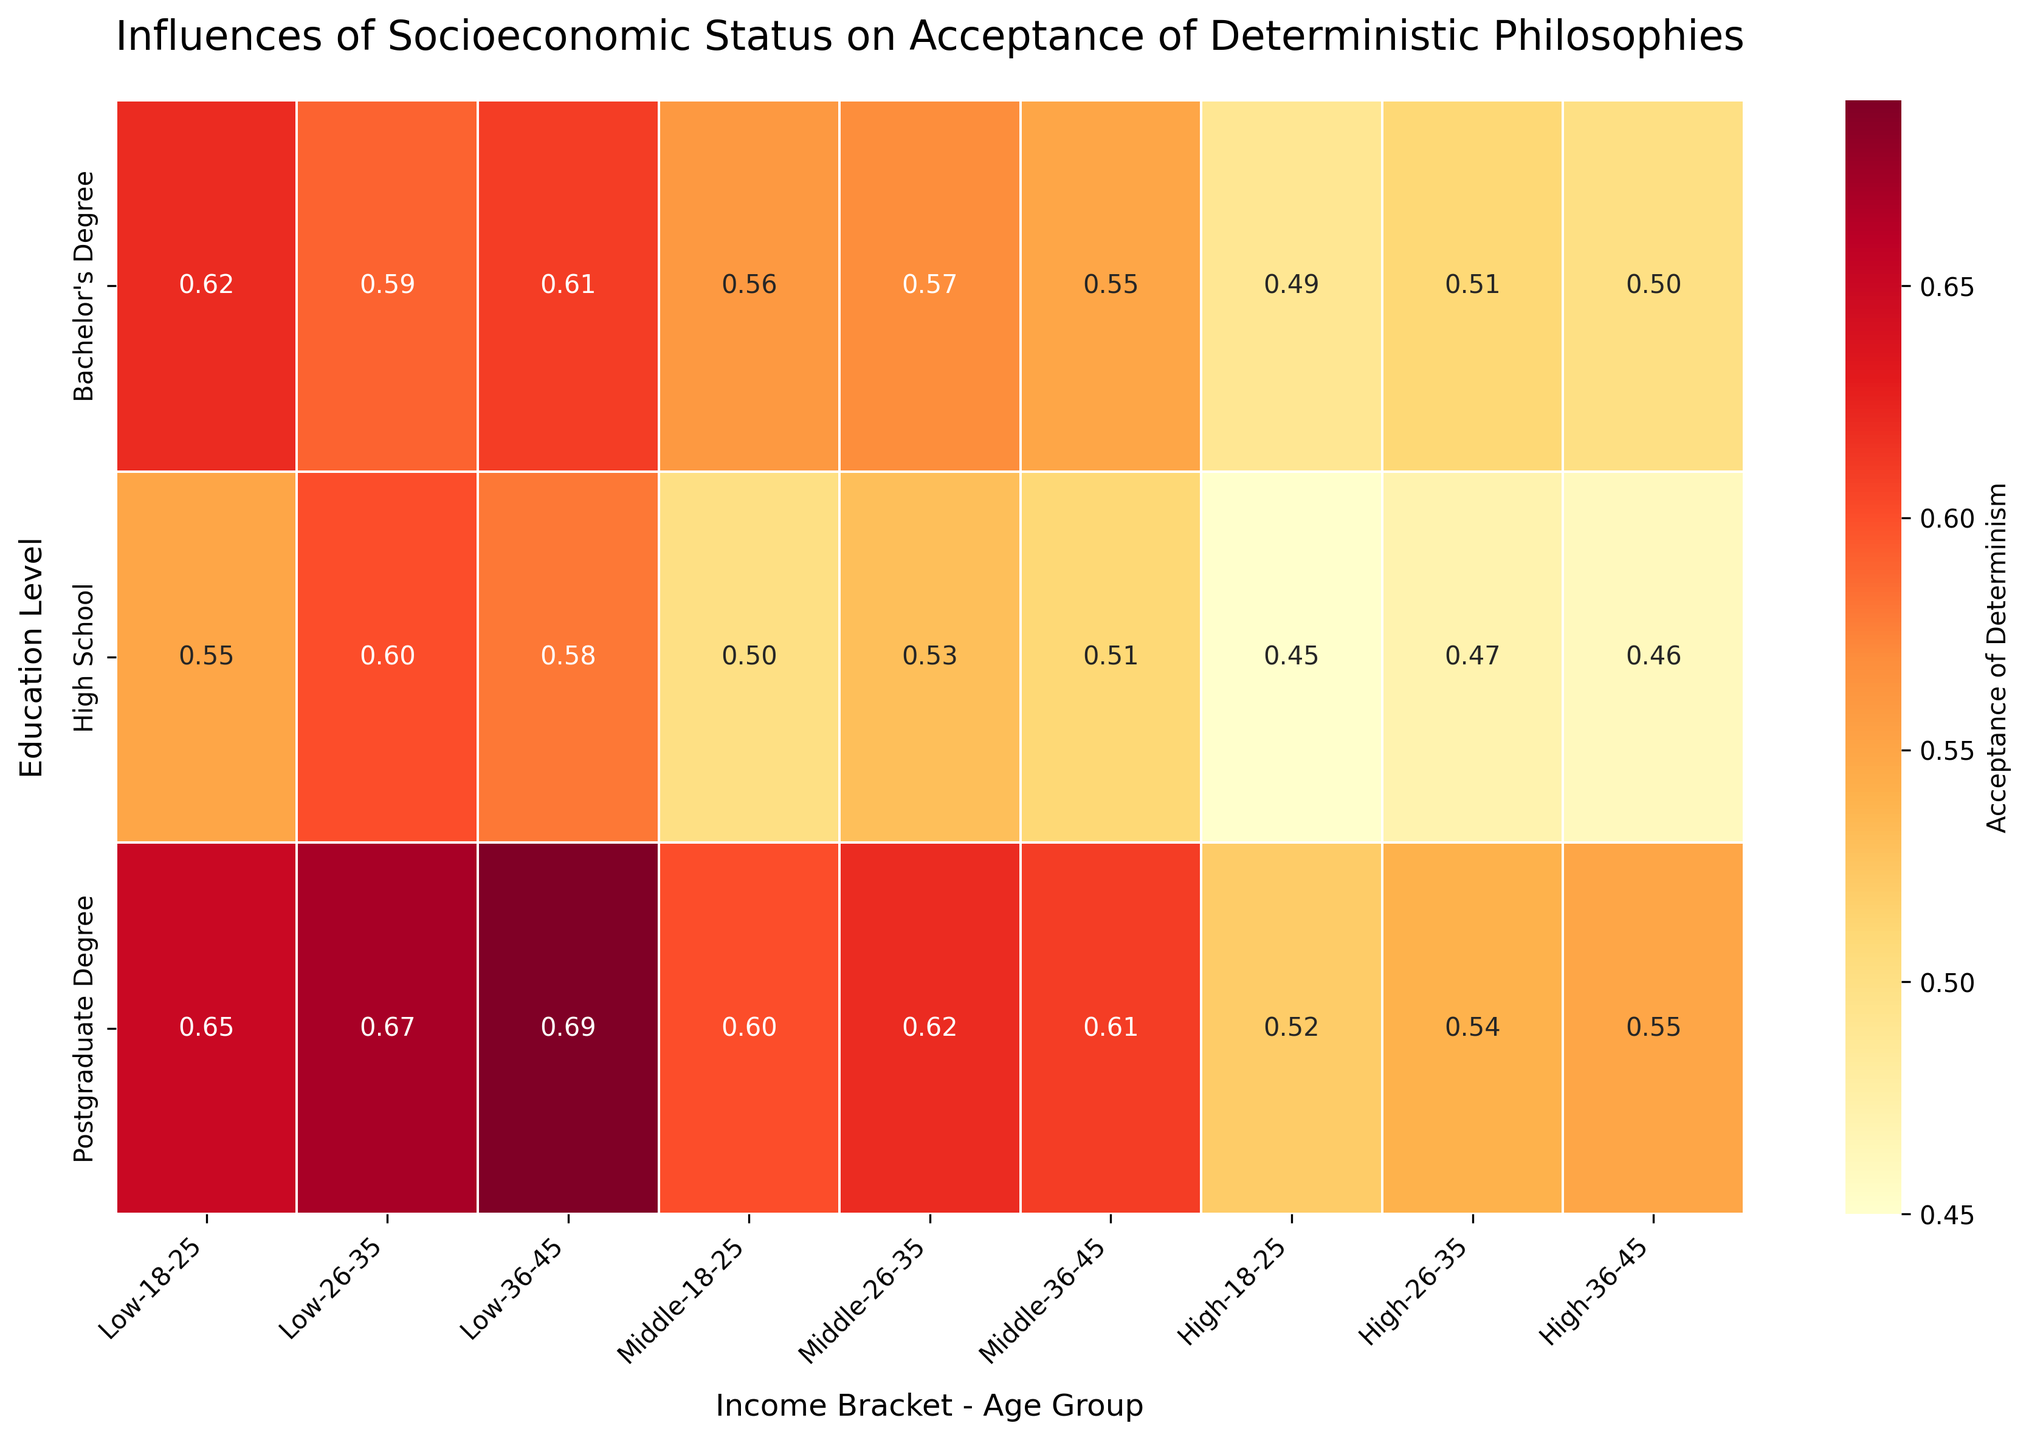What is the title of the figure? The title is usually at the top of the figure displaying the overall topic. Here, "Influences of Socioeconomic Status on Acceptance of Deterministic Philosophies" is visible at the top.
Answer: Influences of Socioeconomic Status on Acceptance of Deterministic Philosophies Which age group and income bracket combination shows the highest acceptance of determinism? Look for the highest value in the heatmap and trace it back to its corresponding age group and income bracket. The cell with the value of 0.69 under Low income and age group 36-45 has the highest acceptance.
Answer: Low income, 36-45 How does the acceptance of determinism for individuals with a High School education and age group 18-25 change across different income brackets? Identify the values for "High School" education level and age group "18-25" for each income bracket. For Low, Middle, and High income, the acceptance rates are 0.55, 0.50, and 0.45, respectively.
Answer: It decreases from 0.55 (Low) to 0.50 (Middle) to 0.45 (High) What is the overall trend in acceptance of determinism with increasing education levels within the Low income bracket? Check the values for each education level within the Low income bracket. For High School, Bachelor's, and Postgraduate degrees, the values are 0.55-0.60, 0.62-0.61, 0.65-0.69, respectively, indicating an increasing trend.
Answer: Acceptance increases with higher education levels Compare the acceptance of determinism between individuals with a Bachelor's Degree and Postgraduate Degree within the Middle income bracket for the age group 26-35. Look at the acceptance values for the Middle income bracket, age group 26-35, specifically for Bachelor's Degree and Postgraduate Degree. The values are 0.57 for Bachelor's and 0.62 for Postgraduate.
Answer: 0.62 is higher than 0.57 for the Postgraduate Degree Which education level within the High income bracket has the most uniform acceptance of determinism across all age groups? Identify the most uniform values by checking the variation across the age groups for each education level. High School (0.45-0.47), Bachelor's (0.49-0.51), and Postgraduate Degree (0.52-0.55) show that the Bachelor's Degree has the least variation.
Answer: Bachelor's Degree What is the average acceptance of determinism for Middle income bracket across all age groups and education levels? Calculate the mean of all values in the Middle income bracket: (0.50 + 0.53 + 0.51 + 0.56 + 0.57 + 0.55 + 0.60 + 0.62 + 0.61) / 9. The sum is 5.05, and the average is 5.05/9.
Answer: 0.56 Is there a trend in acceptance of determinism with age within the Low income bracket and High School education level? Check the values for "Low" income and "High School" education for the age groups 18-25, 26-35, and 36-45. The values are 0.55, 0.60, and 0.58, showing a peak at 26-35.
Answer: Peaks at 26-35 Compare the acceptance rates between the highest and lowest education levels for the 18-25 age group across all income brackets. Identify the values for 18-25 for High School and Postgraduate across Low, Middle, and High income brackets. Low: (0.55-0.65), Middle: (0.50-0.60), High: (0.45-0.52). 0.52 vs. 0.45 for High, 0.55 vs. 0.50 for Middle, and 0.65 vs. 0.55 for Low.
Answer: Higher for Postgraduate in all cases What is the range of acceptance rates among those with a Bachelor's Degree within the High income bracket? Find the minimum and maximum values among those with a Bachelor's Degree in the High income bracket: (0.49, 0.51, 0.50). The range is the difference between the maximum and minimum values, 0.51-0.49.
Answer: 0.02 